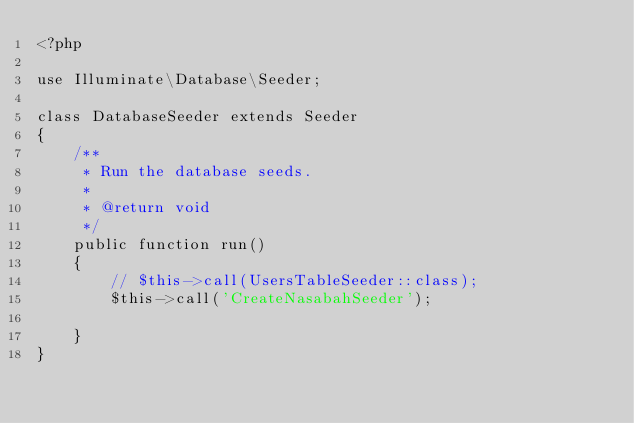<code> <loc_0><loc_0><loc_500><loc_500><_PHP_><?php

use Illuminate\Database\Seeder;

class DatabaseSeeder extends Seeder
{
    /**
     * Run the database seeds.
     *
     * @return void
     */
    public function run()
    {
        // $this->call(UsersTableSeeder::class);
        $this->call('CreateNasabahSeeder');
        
    }
}
</code> 